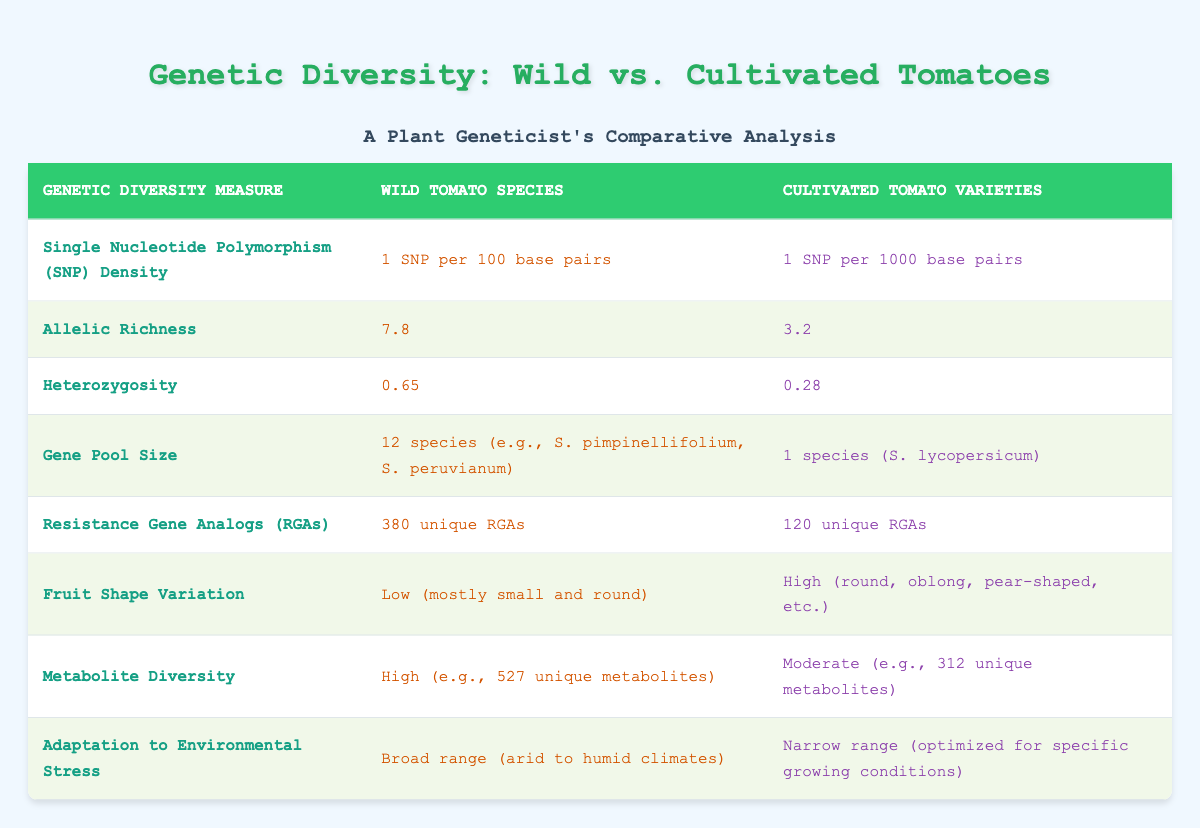What is the SNP density for wild tomato species? According to the table, the SNP density for wild tomato species is listed as "1 SNP per 100 base pairs."
Answer: 1 SNP per 100 base pairs How many unique resistance gene analogs are found in cultivated tomato varieties? The table shows that cultivated tomato varieties have "120 unique RGAs."
Answer: 120 unique RGAs What is the difference in allelic richness between wild and cultivated tomatoes? Wild tomatoes have an allelic richness of 7.8, while cultivated tomatoes have 3.2. The difference is calculated as 7.8 - 3.2 = 4.6.
Answer: 4.6 Is the heterozygosity higher in wild tomato species than in cultivated varieties? The table shows that the heterozygosity for wild tomatoes is 0.65, and for cultivated tomatoes, it is 0.28. Since 0.65 is greater than 0.28, the statement is true.
Answer: Yes How many species contribute to the gene pool of wild tomatoes compared to cultivated tomatoes? The table indicates that wild tomatoes have a gene pool size of "12 species," while cultivated tomatoes consist of "1 species." Comparing these figures, wild tomatoes have 11 more species contributing to their gene pool.
Answer: 11 more species What is the metabolite diversity difference between wild and cultivated tomatoes? Wild tomatoes have a metabolite diversity described as "High (e.g., 527 unique metabolites)", while cultivated tomatoes are noted to have "Moderate (e.g., 312 unique metabolites)." The difference calculated is 527 - 312 = 215 unique metabolites.
Answer: 215 unique metabolites Do cultivated tomato varieties show high fruit shape variation? The table indicates that cultivated tomatoes have "High (round, oblong, pear-shaped, etc.)" variation in fruit shape. Therefore, the answer to the question is true.
Answer: No What can be inferred about the adaptation ranges of wild versus cultivated tomatoes? The table states that wild tomatoes can adapt to a "Broad range (arid to humid climates)," while cultivated tomatoes only have a "Narrow range (optimized for specific growing conditions)." Hence, wild tomatoes have a broader adaptation range than cultivated.
Answer: Wild tomatoes have a broader adaptation range If one were to average the heterozygosity of both groups, what would it be? The heterozygosity values are 0.65 for wild tomatoes and 0.28 for cultivated tomatoes. The average is calculated as (0.65 + 0.28) / 2 = 0.465.
Answer: 0.465 